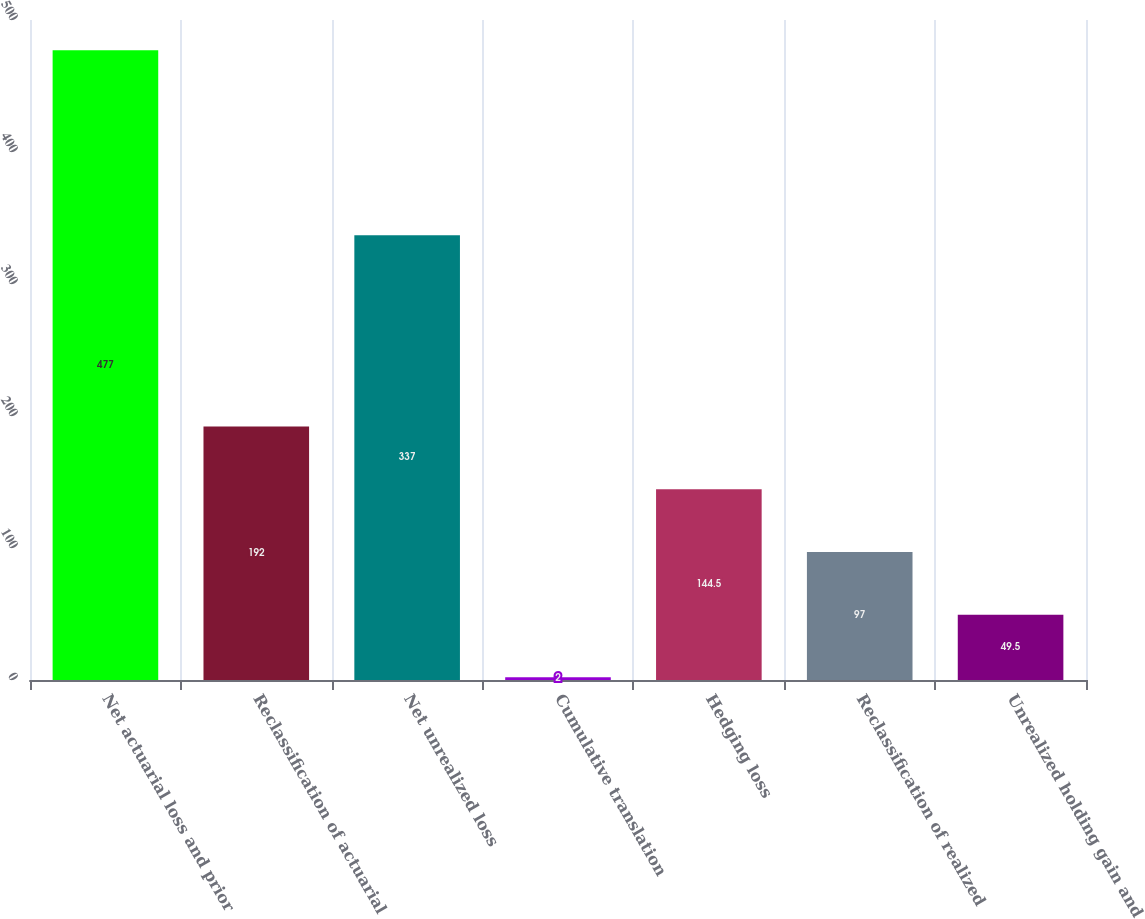Convert chart. <chart><loc_0><loc_0><loc_500><loc_500><bar_chart><fcel>Net actuarial loss and prior<fcel>Reclassification of actuarial<fcel>Net unrealized loss<fcel>Cumulative translation<fcel>Hedging loss<fcel>Reclassification of realized<fcel>Unrealized holding gain and<nl><fcel>477<fcel>192<fcel>337<fcel>2<fcel>144.5<fcel>97<fcel>49.5<nl></chart> 